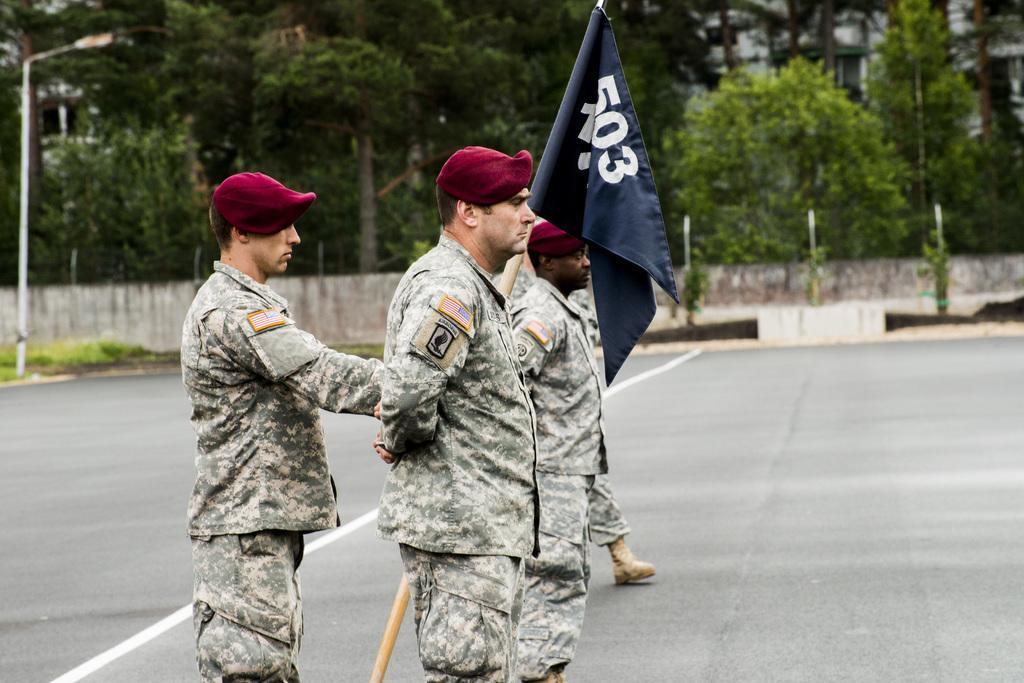Can you describe this image briefly? In this image we can see a few persons standing on the road, one of them is holding a flag. In the background of the image there is a utility pole and some trees. 